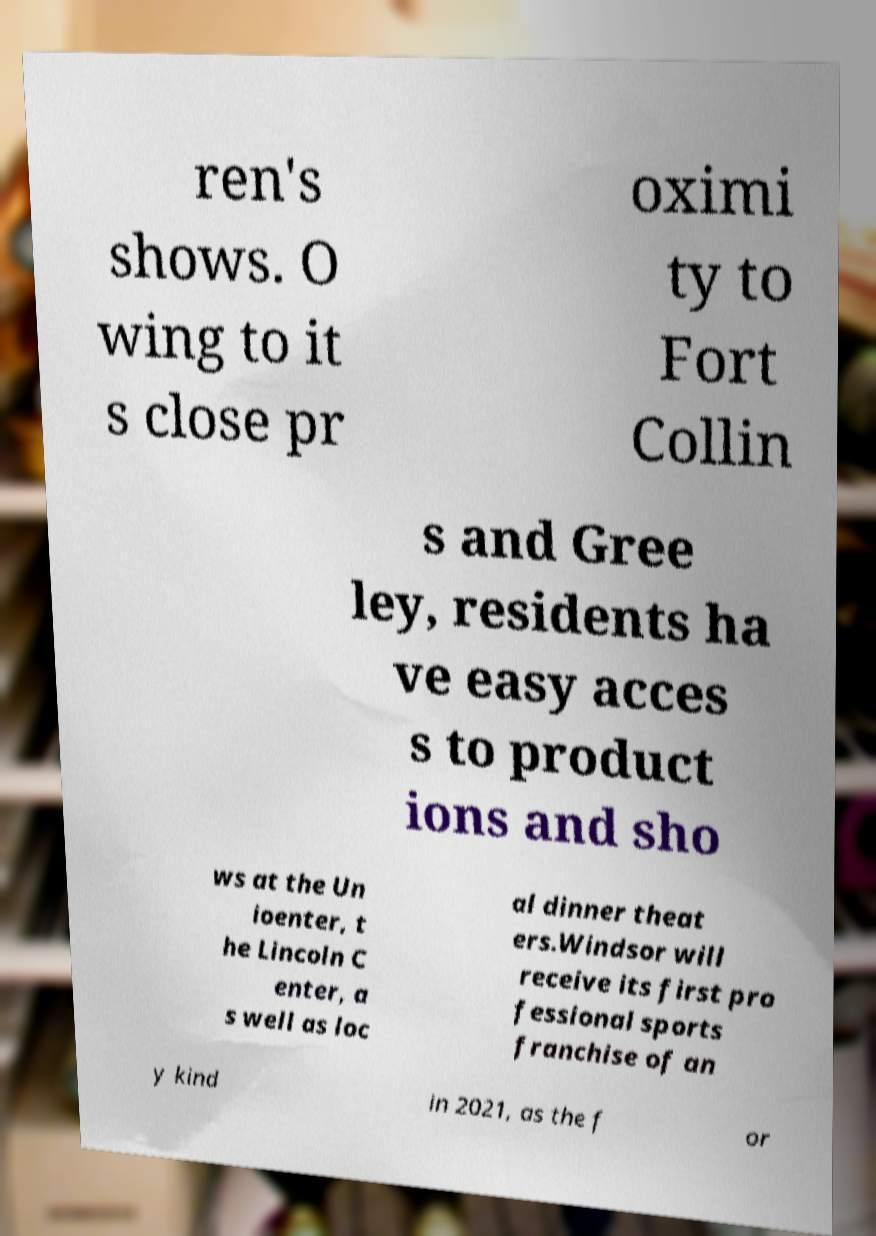Could you assist in decoding the text presented in this image and type it out clearly? ren's shows. O wing to it s close pr oximi ty to Fort Collin s and Gree ley, residents ha ve easy acces s to product ions and sho ws at the Un ioenter, t he Lincoln C enter, a s well as loc al dinner theat ers.Windsor will receive its first pro fessional sports franchise of an y kind in 2021, as the f or 